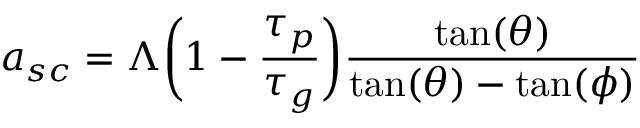<formula> <loc_0><loc_0><loc_500><loc_500>a _ { s c } = \Lambda \left ( 1 - \frac { \tau _ { p } } { \tau _ { g } } \right ) \frac { \tan ( \theta ) } { \tan ( \theta ) - \tan ( \phi ) }</formula> 